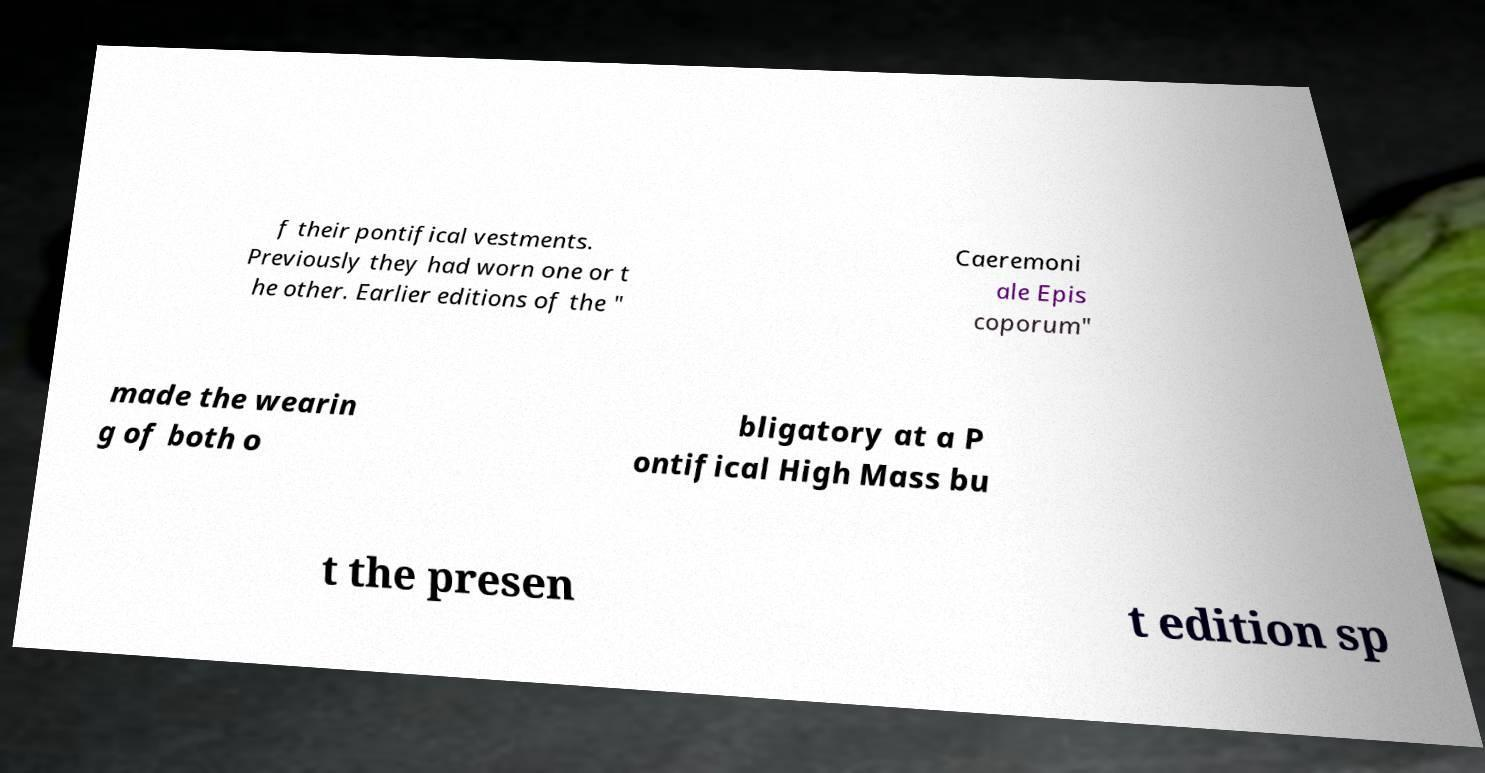Could you assist in decoding the text presented in this image and type it out clearly? f their pontifical vestments. Previously they had worn one or t he other. Earlier editions of the " Caeremoni ale Epis coporum" made the wearin g of both o bligatory at a P ontifical High Mass bu t the presen t edition sp 